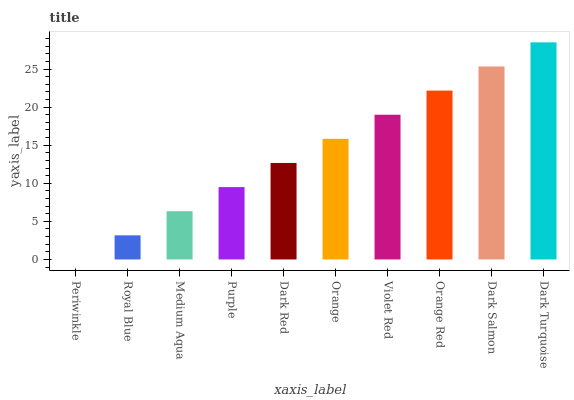Is Periwinkle the minimum?
Answer yes or no. Yes. Is Dark Turquoise the maximum?
Answer yes or no. Yes. Is Royal Blue the minimum?
Answer yes or no. No. Is Royal Blue the maximum?
Answer yes or no. No. Is Royal Blue greater than Periwinkle?
Answer yes or no. Yes. Is Periwinkle less than Royal Blue?
Answer yes or no. Yes. Is Periwinkle greater than Royal Blue?
Answer yes or no. No. Is Royal Blue less than Periwinkle?
Answer yes or no. No. Is Orange the high median?
Answer yes or no. Yes. Is Dark Red the low median?
Answer yes or no. Yes. Is Dark Turquoise the high median?
Answer yes or no. No. Is Dark Turquoise the low median?
Answer yes or no. No. 